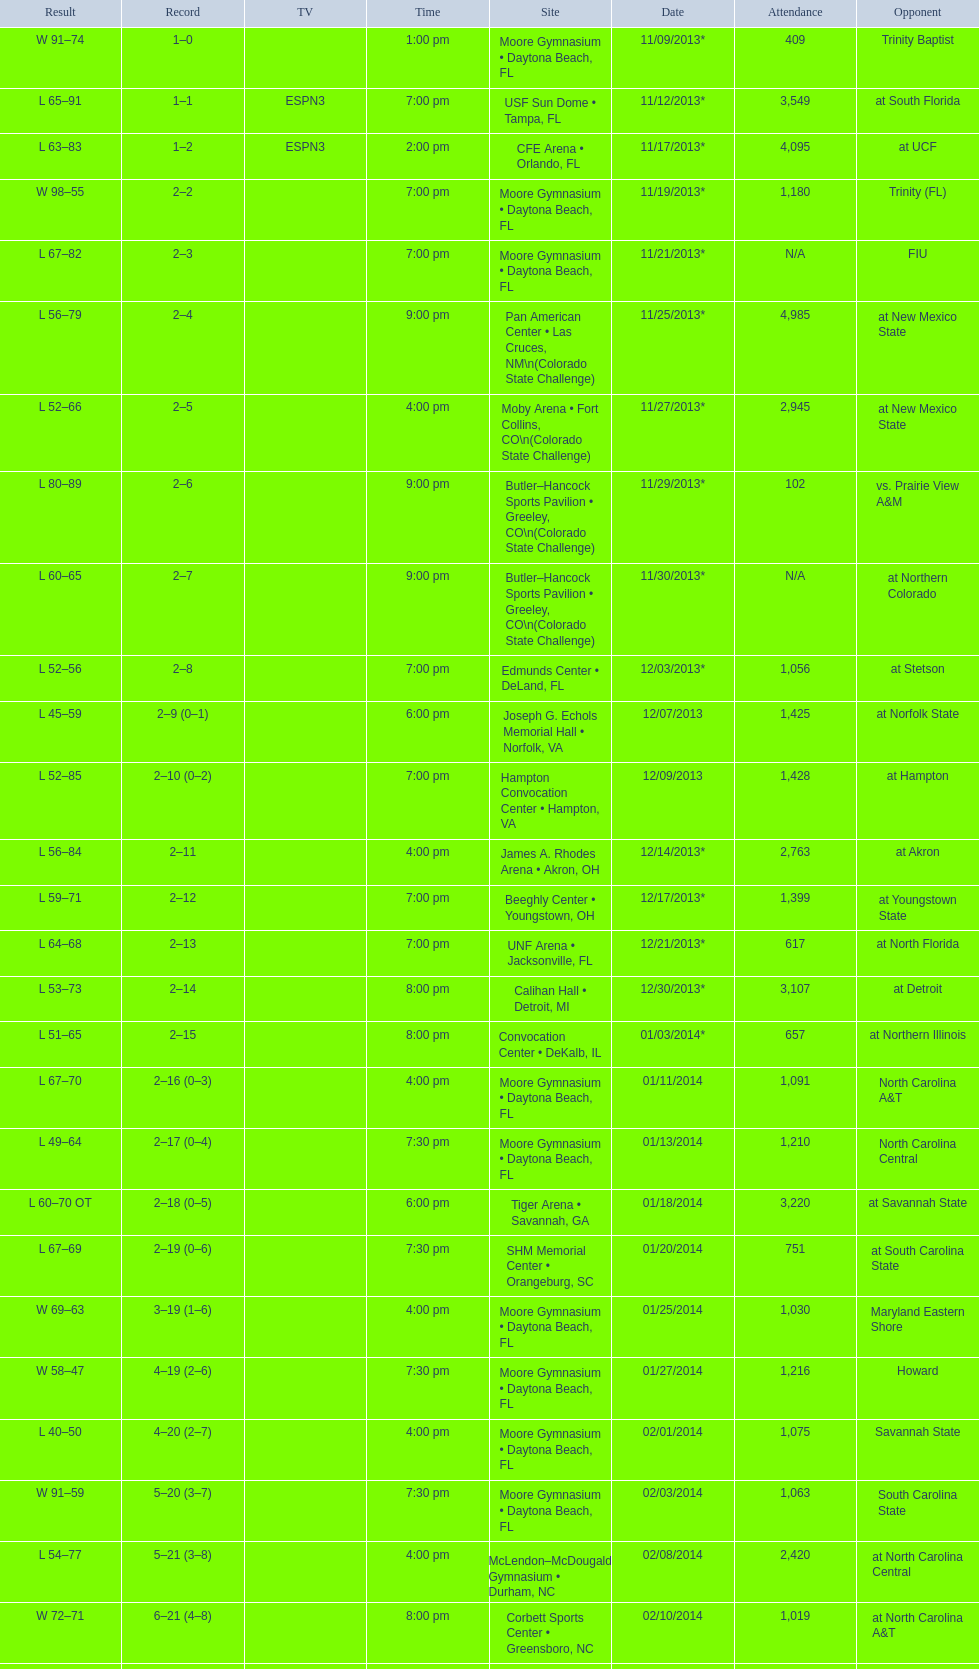How many games did the wildcats play in daytona beach, fl? 11. 